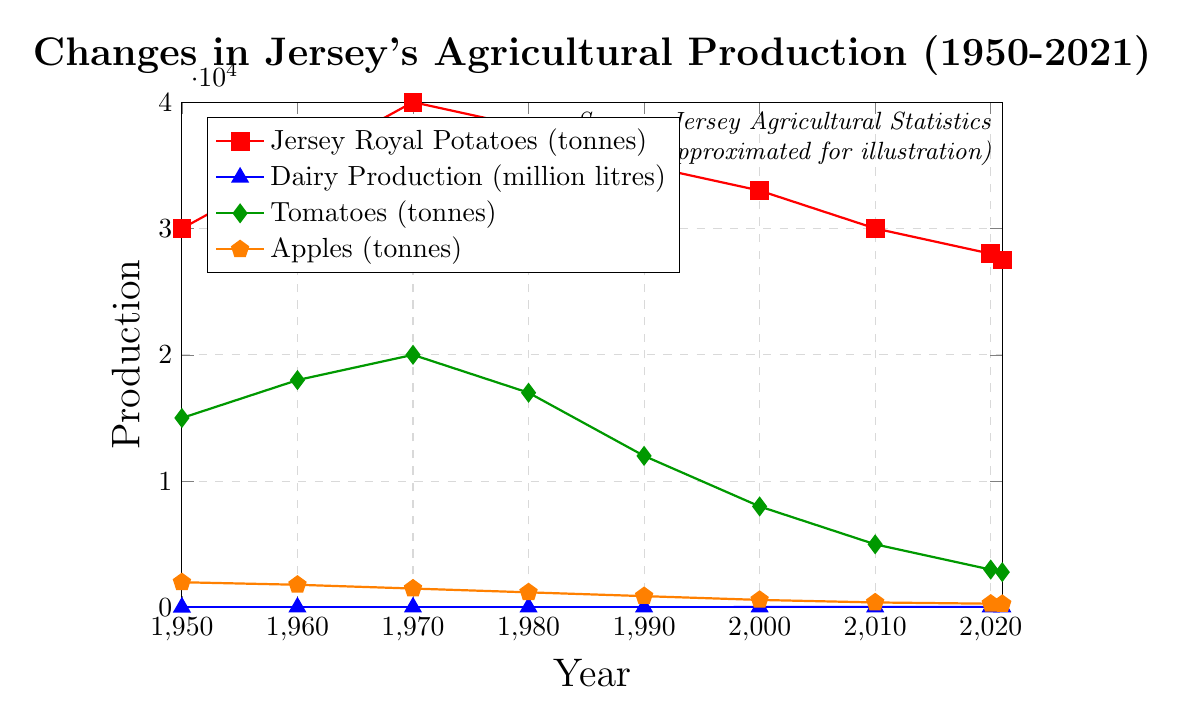What crop had the highest production in 1970? Looking at the plot, we can see each line representing different crops. In 1970, Jersey Royal Potatoes have a value of 40000, Dairy Production is 25, Tomatoes are 20000, and Apples are 1500. The highest value among these is 40000 for Jersey Royal Potatoes.
Answer: Jersey Royal Potatoes Compare the trend of dairy production and tomato production from 1990 to 2021. From the plot, Dairy Production shows a steady increase from 30 million litres in 1990 to 35.5 million litres in 2021. On the other hand, Tomato production shows a steep decline from 12000 tonnes in 1990 to 2800 tonnes in 2021.
Answer: Dairy Production increased while Tomato Production decreased What is the average production of Jersey Royal Potatoes from 2000 to 2021? The values from 2000 to 2021 for Jersey Royal Potatoes are 33000, 30000, 28000, and 27500. Sum these values: 33000 + 30000 + 28000 + 27500 = 118500. Divide by the number of years: 118500 / 4 = 29625.
Answer: 29625 In which year did dairy production first exceed 30 million litres? Refer to the plot for Dairy Production. Dairy Production reaches 30 million litres in 1990 and exceeds it for the first time in 2000 (32 million litres).
Answer: 2000 How did apple and potato production compare in 1950 and 2020? In 1950, Apple production was 2000 tonnes, and Jersey Royal Potatoes produced 30000 tonnes. In 2020, Apple production was 300 tonnes, and Jersey Royal Potatoes produced 28000 tonnes. Both crops saw a significant reduction in production over these years, with apples decreasing more dramatically.
Answer: Both decreased, apples more dramatically By how much did tomato production decrease from 1950 to 2021? Initially, tomato production in 1950 was 15000 tonnes. By 2021, it decreased to 2800 tonnes. The difference is 15000 - 2800 = 12200 tonnes.
Answer: 12200 tonnes What is the visual indication for the crop that decreased the most in production from 1950 to 2021? Look at the steepest slope downwards on the plot. Apples, represented by the orange pentagon markers, show a steep decline from 2000 to 280.
Answer: Apples Comparatively, which had the smallest decline in production from 1980 to 2021: Apples or Tomatoes? In 1980, Apple production was 1200 tonnes, and by 2021, it was 280 tonnes. The difference is 1200 - 280 = 920 tonnes. For Tomatoes, production was 17000 tonnes in 1980 and 2800 tonnes in 2021, giving a difference of 17000 - 2800 = 14200 tonnes. Apples had a smaller decline.
Answer: Apples 